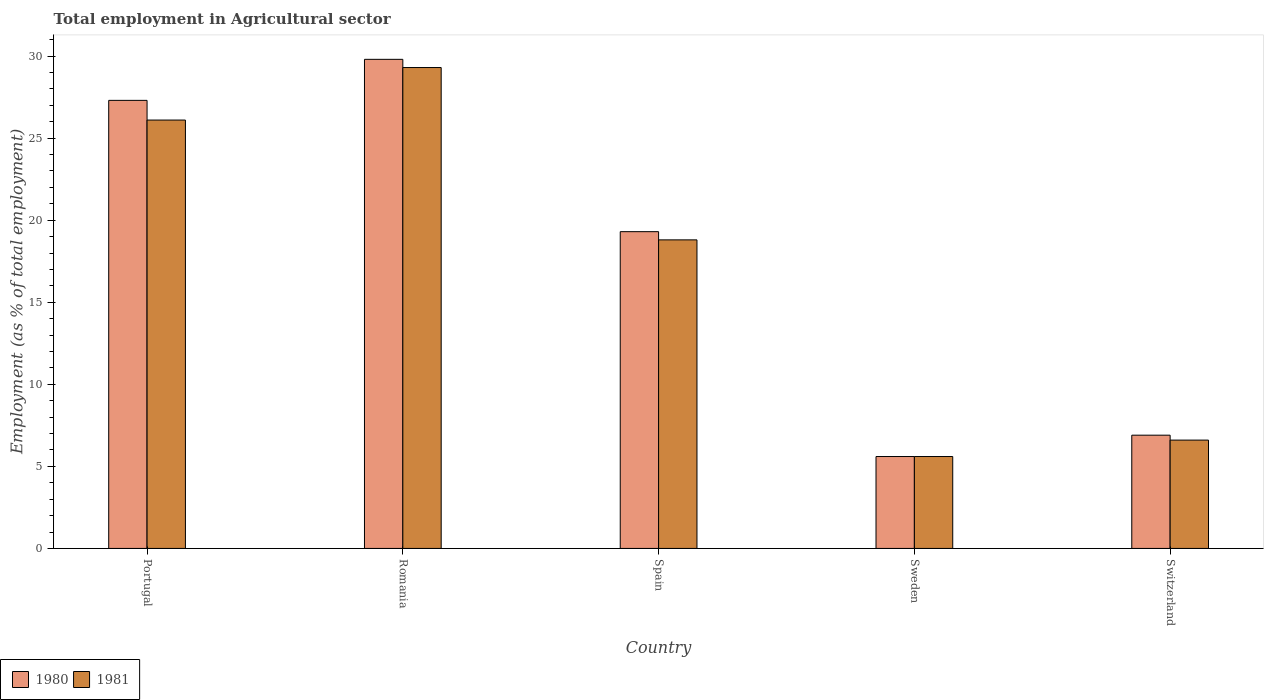How many different coloured bars are there?
Give a very brief answer. 2. Are the number of bars per tick equal to the number of legend labels?
Your answer should be compact. Yes. How many bars are there on the 3rd tick from the left?
Your response must be concise. 2. What is the label of the 3rd group of bars from the left?
Keep it short and to the point. Spain. What is the employment in agricultural sector in 1980 in Spain?
Provide a succinct answer. 19.3. Across all countries, what is the maximum employment in agricultural sector in 1980?
Give a very brief answer. 29.8. Across all countries, what is the minimum employment in agricultural sector in 1980?
Make the answer very short. 5.6. In which country was the employment in agricultural sector in 1981 maximum?
Your answer should be very brief. Romania. In which country was the employment in agricultural sector in 1981 minimum?
Provide a succinct answer. Sweden. What is the total employment in agricultural sector in 1981 in the graph?
Make the answer very short. 86.4. What is the difference between the employment in agricultural sector in 1981 in Spain and that in Sweden?
Your answer should be very brief. 13.2. What is the difference between the employment in agricultural sector in 1980 in Portugal and the employment in agricultural sector in 1981 in Romania?
Your response must be concise. -2. What is the average employment in agricultural sector in 1980 per country?
Your response must be concise. 17.78. What is the difference between the employment in agricultural sector of/in 1981 and employment in agricultural sector of/in 1980 in Spain?
Provide a short and direct response. -0.5. What is the ratio of the employment in agricultural sector in 1980 in Portugal to that in Switzerland?
Your response must be concise. 3.96. Is the employment in agricultural sector in 1981 in Romania less than that in Sweden?
Provide a short and direct response. No. What is the difference between the highest and the second highest employment in agricultural sector in 1980?
Offer a very short reply. -8. What is the difference between the highest and the lowest employment in agricultural sector in 1980?
Ensure brevity in your answer.  24.2. In how many countries, is the employment in agricultural sector in 1981 greater than the average employment in agricultural sector in 1981 taken over all countries?
Provide a succinct answer. 3. What does the 2nd bar from the left in Spain represents?
Keep it short and to the point. 1981. How many bars are there?
Offer a very short reply. 10. What is the difference between two consecutive major ticks on the Y-axis?
Offer a terse response. 5. Does the graph contain grids?
Keep it short and to the point. No. How many legend labels are there?
Offer a very short reply. 2. How are the legend labels stacked?
Ensure brevity in your answer.  Horizontal. What is the title of the graph?
Make the answer very short. Total employment in Agricultural sector. What is the label or title of the X-axis?
Provide a succinct answer. Country. What is the label or title of the Y-axis?
Offer a very short reply. Employment (as % of total employment). What is the Employment (as % of total employment) in 1980 in Portugal?
Provide a succinct answer. 27.3. What is the Employment (as % of total employment) of 1981 in Portugal?
Your response must be concise. 26.1. What is the Employment (as % of total employment) of 1980 in Romania?
Give a very brief answer. 29.8. What is the Employment (as % of total employment) of 1981 in Romania?
Your answer should be very brief. 29.3. What is the Employment (as % of total employment) of 1980 in Spain?
Make the answer very short. 19.3. What is the Employment (as % of total employment) in 1981 in Spain?
Offer a very short reply. 18.8. What is the Employment (as % of total employment) in 1980 in Sweden?
Provide a succinct answer. 5.6. What is the Employment (as % of total employment) in 1981 in Sweden?
Offer a terse response. 5.6. What is the Employment (as % of total employment) of 1980 in Switzerland?
Provide a short and direct response. 6.9. What is the Employment (as % of total employment) in 1981 in Switzerland?
Provide a succinct answer. 6.6. Across all countries, what is the maximum Employment (as % of total employment) in 1980?
Provide a succinct answer. 29.8. Across all countries, what is the maximum Employment (as % of total employment) of 1981?
Your answer should be compact. 29.3. Across all countries, what is the minimum Employment (as % of total employment) of 1980?
Keep it short and to the point. 5.6. Across all countries, what is the minimum Employment (as % of total employment) in 1981?
Give a very brief answer. 5.6. What is the total Employment (as % of total employment) in 1980 in the graph?
Offer a terse response. 88.9. What is the total Employment (as % of total employment) of 1981 in the graph?
Offer a very short reply. 86.4. What is the difference between the Employment (as % of total employment) in 1980 in Portugal and that in Romania?
Your answer should be very brief. -2.5. What is the difference between the Employment (as % of total employment) of 1981 in Portugal and that in Romania?
Your response must be concise. -3.2. What is the difference between the Employment (as % of total employment) in 1980 in Portugal and that in Sweden?
Provide a succinct answer. 21.7. What is the difference between the Employment (as % of total employment) in 1980 in Portugal and that in Switzerland?
Provide a short and direct response. 20.4. What is the difference between the Employment (as % of total employment) of 1981 in Portugal and that in Switzerland?
Give a very brief answer. 19.5. What is the difference between the Employment (as % of total employment) in 1981 in Romania and that in Spain?
Ensure brevity in your answer.  10.5. What is the difference between the Employment (as % of total employment) of 1980 in Romania and that in Sweden?
Offer a terse response. 24.2. What is the difference between the Employment (as % of total employment) of 1981 in Romania and that in Sweden?
Your response must be concise. 23.7. What is the difference between the Employment (as % of total employment) in 1980 in Romania and that in Switzerland?
Your answer should be compact. 22.9. What is the difference between the Employment (as % of total employment) in 1981 in Romania and that in Switzerland?
Offer a terse response. 22.7. What is the difference between the Employment (as % of total employment) of 1980 in Spain and that in Sweden?
Your answer should be very brief. 13.7. What is the difference between the Employment (as % of total employment) of 1981 in Spain and that in Switzerland?
Keep it short and to the point. 12.2. What is the difference between the Employment (as % of total employment) in 1980 in Portugal and the Employment (as % of total employment) in 1981 in Sweden?
Make the answer very short. 21.7. What is the difference between the Employment (as % of total employment) in 1980 in Portugal and the Employment (as % of total employment) in 1981 in Switzerland?
Offer a terse response. 20.7. What is the difference between the Employment (as % of total employment) in 1980 in Romania and the Employment (as % of total employment) in 1981 in Sweden?
Your answer should be very brief. 24.2. What is the difference between the Employment (as % of total employment) of 1980 in Romania and the Employment (as % of total employment) of 1981 in Switzerland?
Offer a very short reply. 23.2. What is the difference between the Employment (as % of total employment) of 1980 in Spain and the Employment (as % of total employment) of 1981 in Switzerland?
Ensure brevity in your answer.  12.7. What is the difference between the Employment (as % of total employment) of 1980 in Sweden and the Employment (as % of total employment) of 1981 in Switzerland?
Keep it short and to the point. -1. What is the average Employment (as % of total employment) of 1980 per country?
Your answer should be compact. 17.78. What is the average Employment (as % of total employment) in 1981 per country?
Your response must be concise. 17.28. What is the difference between the Employment (as % of total employment) in 1980 and Employment (as % of total employment) in 1981 in Portugal?
Your answer should be very brief. 1.2. What is the ratio of the Employment (as % of total employment) in 1980 in Portugal to that in Romania?
Your answer should be compact. 0.92. What is the ratio of the Employment (as % of total employment) of 1981 in Portugal to that in Romania?
Offer a terse response. 0.89. What is the ratio of the Employment (as % of total employment) of 1980 in Portugal to that in Spain?
Your answer should be very brief. 1.41. What is the ratio of the Employment (as % of total employment) of 1981 in Portugal to that in Spain?
Make the answer very short. 1.39. What is the ratio of the Employment (as % of total employment) of 1980 in Portugal to that in Sweden?
Your answer should be very brief. 4.88. What is the ratio of the Employment (as % of total employment) of 1981 in Portugal to that in Sweden?
Provide a succinct answer. 4.66. What is the ratio of the Employment (as % of total employment) in 1980 in Portugal to that in Switzerland?
Your answer should be very brief. 3.96. What is the ratio of the Employment (as % of total employment) of 1981 in Portugal to that in Switzerland?
Offer a terse response. 3.95. What is the ratio of the Employment (as % of total employment) of 1980 in Romania to that in Spain?
Give a very brief answer. 1.54. What is the ratio of the Employment (as % of total employment) of 1981 in Romania to that in Spain?
Keep it short and to the point. 1.56. What is the ratio of the Employment (as % of total employment) of 1980 in Romania to that in Sweden?
Your answer should be very brief. 5.32. What is the ratio of the Employment (as % of total employment) of 1981 in Romania to that in Sweden?
Your answer should be compact. 5.23. What is the ratio of the Employment (as % of total employment) of 1980 in Romania to that in Switzerland?
Your answer should be very brief. 4.32. What is the ratio of the Employment (as % of total employment) in 1981 in Romania to that in Switzerland?
Give a very brief answer. 4.44. What is the ratio of the Employment (as % of total employment) in 1980 in Spain to that in Sweden?
Your response must be concise. 3.45. What is the ratio of the Employment (as % of total employment) of 1981 in Spain to that in Sweden?
Make the answer very short. 3.36. What is the ratio of the Employment (as % of total employment) in 1980 in Spain to that in Switzerland?
Your answer should be very brief. 2.8. What is the ratio of the Employment (as % of total employment) in 1981 in Spain to that in Switzerland?
Your answer should be compact. 2.85. What is the ratio of the Employment (as % of total employment) in 1980 in Sweden to that in Switzerland?
Provide a succinct answer. 0.81. What is the ratio of the Employment (as % of total employment) of 1981 in Sweden to that in Switzerland?
Your answer should be very brief. 0.85. What is the difference between the highest and the second highest Employment (as % of total employment) in 1980?
Offer a terse response. 2.5. What is the difference between the highest and the lowest Employment (as % of total employment) in 1980?
Give a very brief answer. 24.2. What is the difference between the highest and the lowest Employment (as % of total employment) in 1981?
Offer a very short reply. 23.7. 